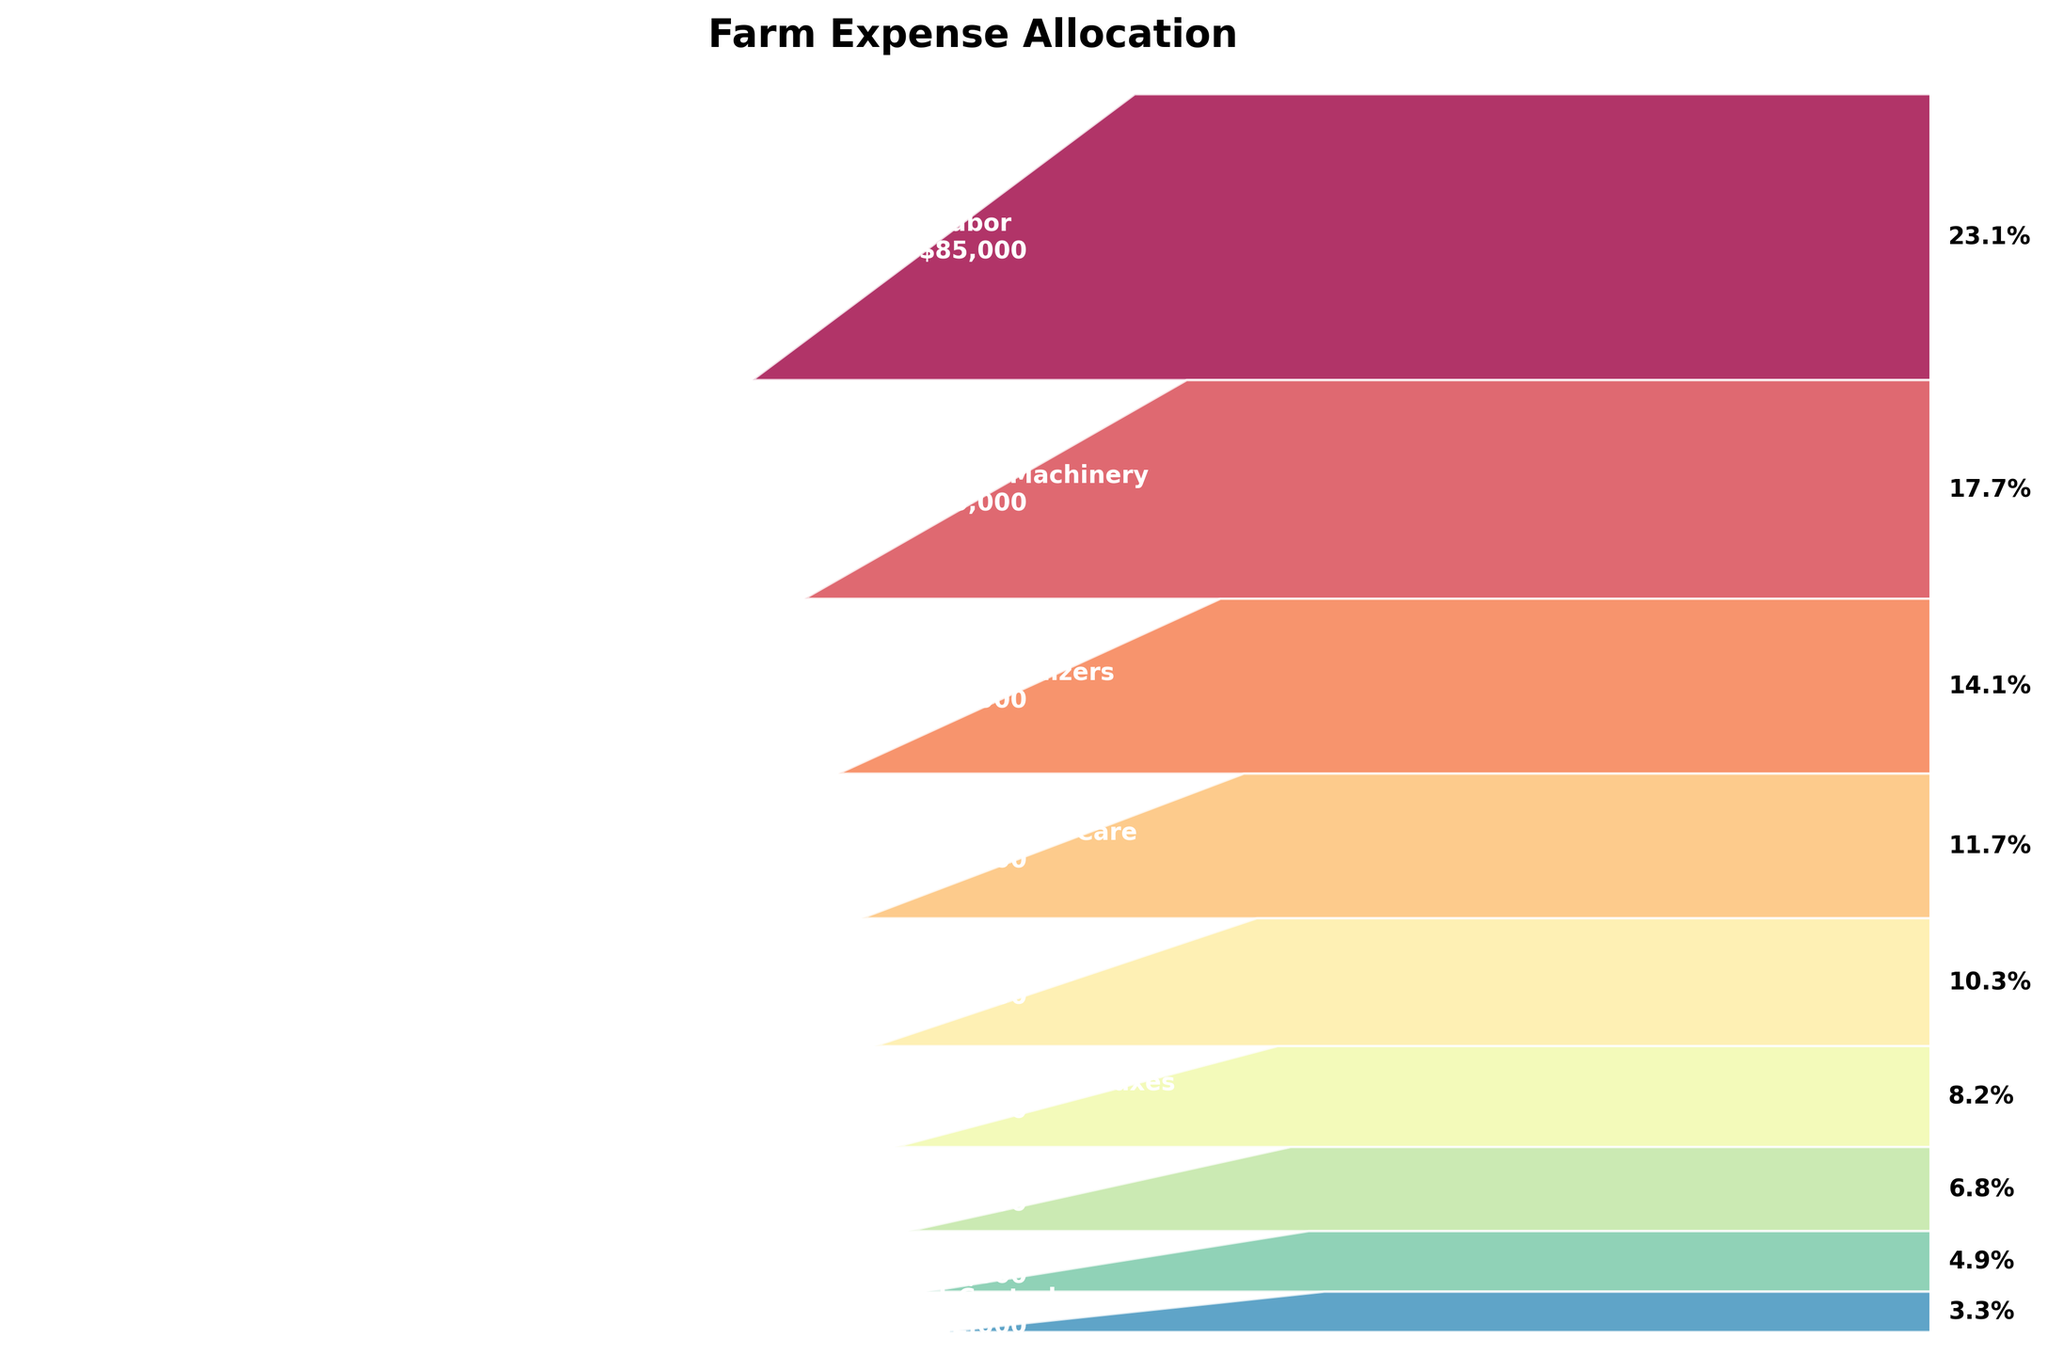how many operational areas are identified in the funnel chart? By observing the different segments in the funnel chart, we can count the number of distinct labeled categories.
Answer: 9 which operational area incurs the highest expense? By identifying the widest segment at the top of the funnel chart, it shows the category "Labor" with $85,000.
Answer: Labor what percentage of the total expenses is allocated to labor? The funnel chart shows a percentage label next to each category; for "Labor," it shows 19.9%.
Answer: 19.9% what is the cumulative percentage of expenses for equipment and machinery and seeds and fertilizers? First, identify the percentages for "Equipment and Machinery" (15.2%) and "Seeds and Fertilizers" (12.2%). Then, add them up: 15.2% + 12.2%.
Answer: 27.4% which category incurs lower expenses compared to fuel and energy? By comparing the labels and their corresponding values, categories "Land Rent and Property Taxes," "Insurance," "Irrigation and Water," and "Pest Control" all have lower expenses than "Fuel and Energy."
Answer: Land Rent and Property Taxes, Insurance, Irrigation and Water, Pest Control what is the difference in expense between livestock feed and care and pest control? Identify the expenses for "Livestock Feed and Care" ($43,000) and "Pest Control" ($12,000). Subtract the smaller value from the larger one: $43,000 - $12,000.
Answer: $31,000 which category accounts for the smallest proportion of the total expenses? By identifying the narrowest segment at the bottom of the funnel chart, "Pest Control" with $12,000.
Answer: Pest Control what is the total expense allocated to the top three categories? Add the expenses for "Labor" ($85,000), "Equipment and Machinery" ($65,000), and "Seeds and Fertilizers" ($52,000): $85,000 + $65,000 + $52,000.
Answer: $202,000 which is larger: the expense for irrigation and water or the expense for insurance? Compare the expenses for "Irrigation and Water" ($18,000) and "Insurance" ($25,000); insurance is larger.
Answer: Insurance 